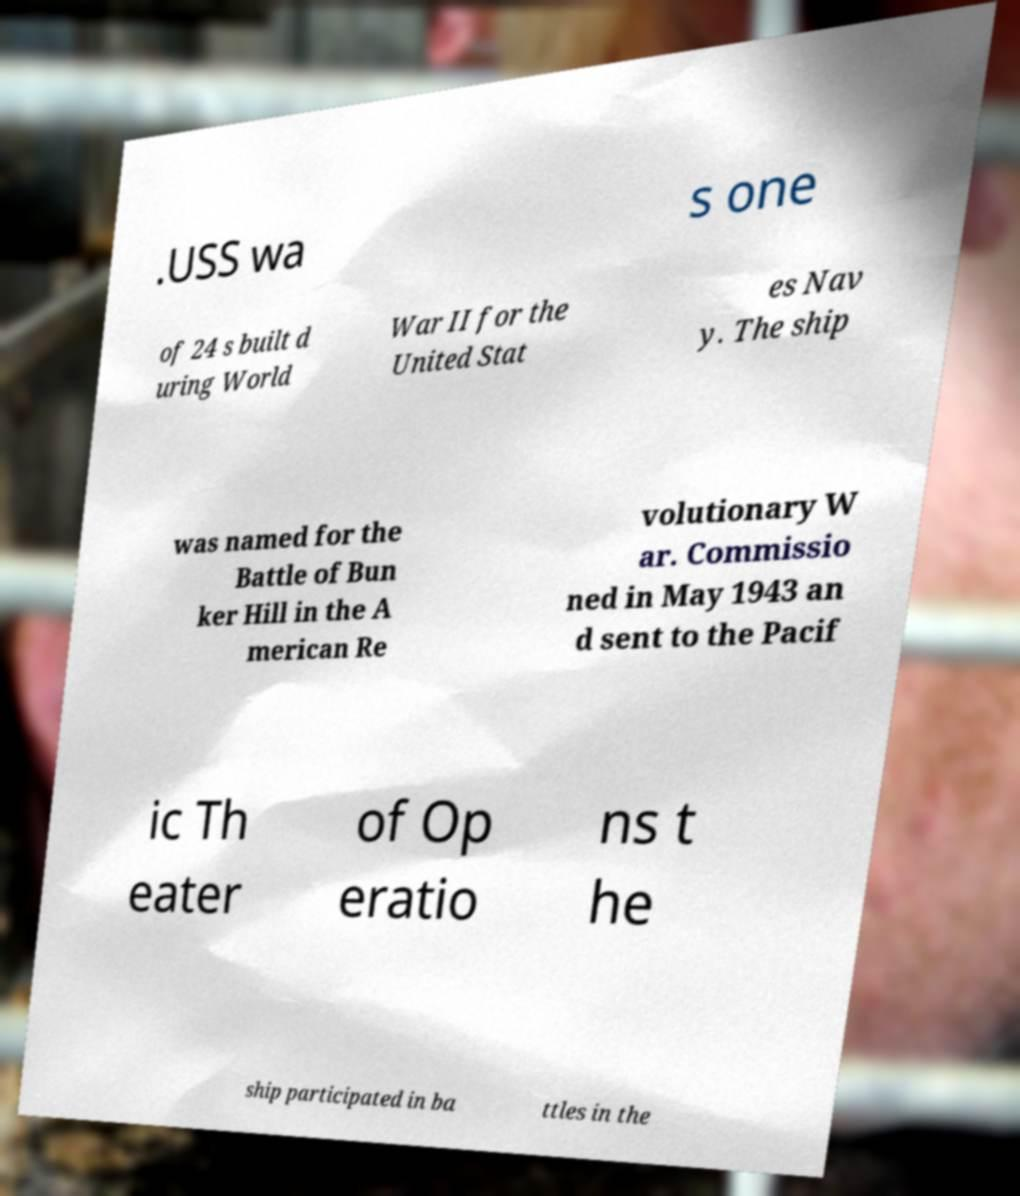Please read and relay the text visible in this image. What does it say? .USS wa s one of 24 s built d uring World War II for the United Stat es Nav y. The ship was named for the Battle of Bun ker Hill in the A merican Re volutionary W ar. Commissio ned in May 1943 an d sent to the Pacif ic Th eater of Op eratio ns t he ship participated in ba ttles in the 